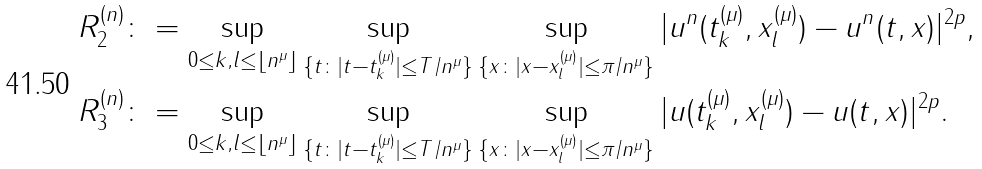Convert formula to latex. <formula><loc_0><loc_0><loc_500><loc_500>R _ { 2 } ^ { ( n ) } \colon & = \sup _ { 0 \leq k , l \leq \lfloor n ^ { \mu } \rfloor } \sup _ { \{ t \colon | t - t _ { k } ^ { ( \mu ) } | \leq T / n ^ { \mu } \} } \sup _ { \{ x \colon | x - x _ { l } ^ { ( \mu ) } | \leq \pi / n ^ { \mu } \} } | u ^ { n } ( t _ { k } ^ { ( \mu ) } , x _ { l } ^ { ( \mu ) } ) - u ^ { n } ( t , x ) | ^ { 2 p } , \\ R _ { 3 } ^ { ( n ) } \colon & = \sup _ { 0 \leq k , l \leq \lfloor n ^ { \mu } \rfloor } \sup _ { \{ t \colon | t - t _ { k } ^ { ( \mu ) } | \leq T / n ^ { \mu } \} } \sup _ { \{ x \colon | x - x _ { l } ^ { ( \mu ) } | \leq \pi / n ^ { \mu } \} } | u ( t _ { k } ^ { ( \mu ) } , x _ { l } ^ { ( \mu ) } ) - u ( t , x ) | ^ { 2 p } .</formula> 